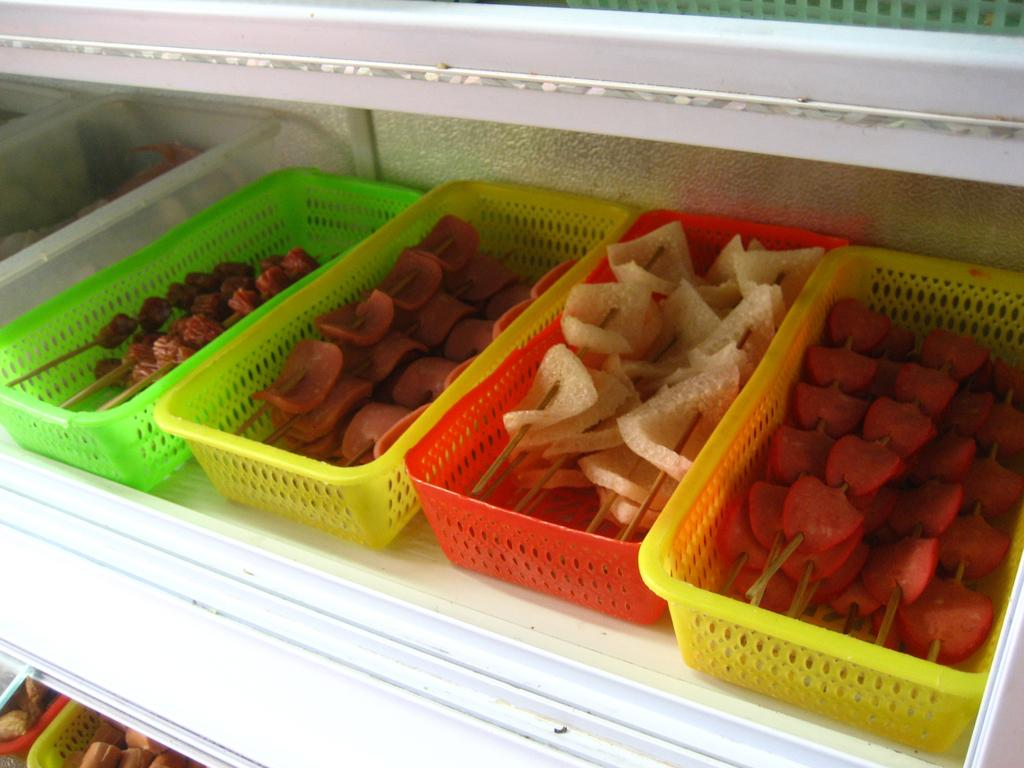What is the person holding in the image? The person is holding a book in the image. What is located in front of the person? There is a desk in front of the person. What object is on the desk? There is a lamp on the desk. What type of bomb can be seen in the image? There is no bomb present in the image; it features a person holding a book, a desk, and a lamp. 